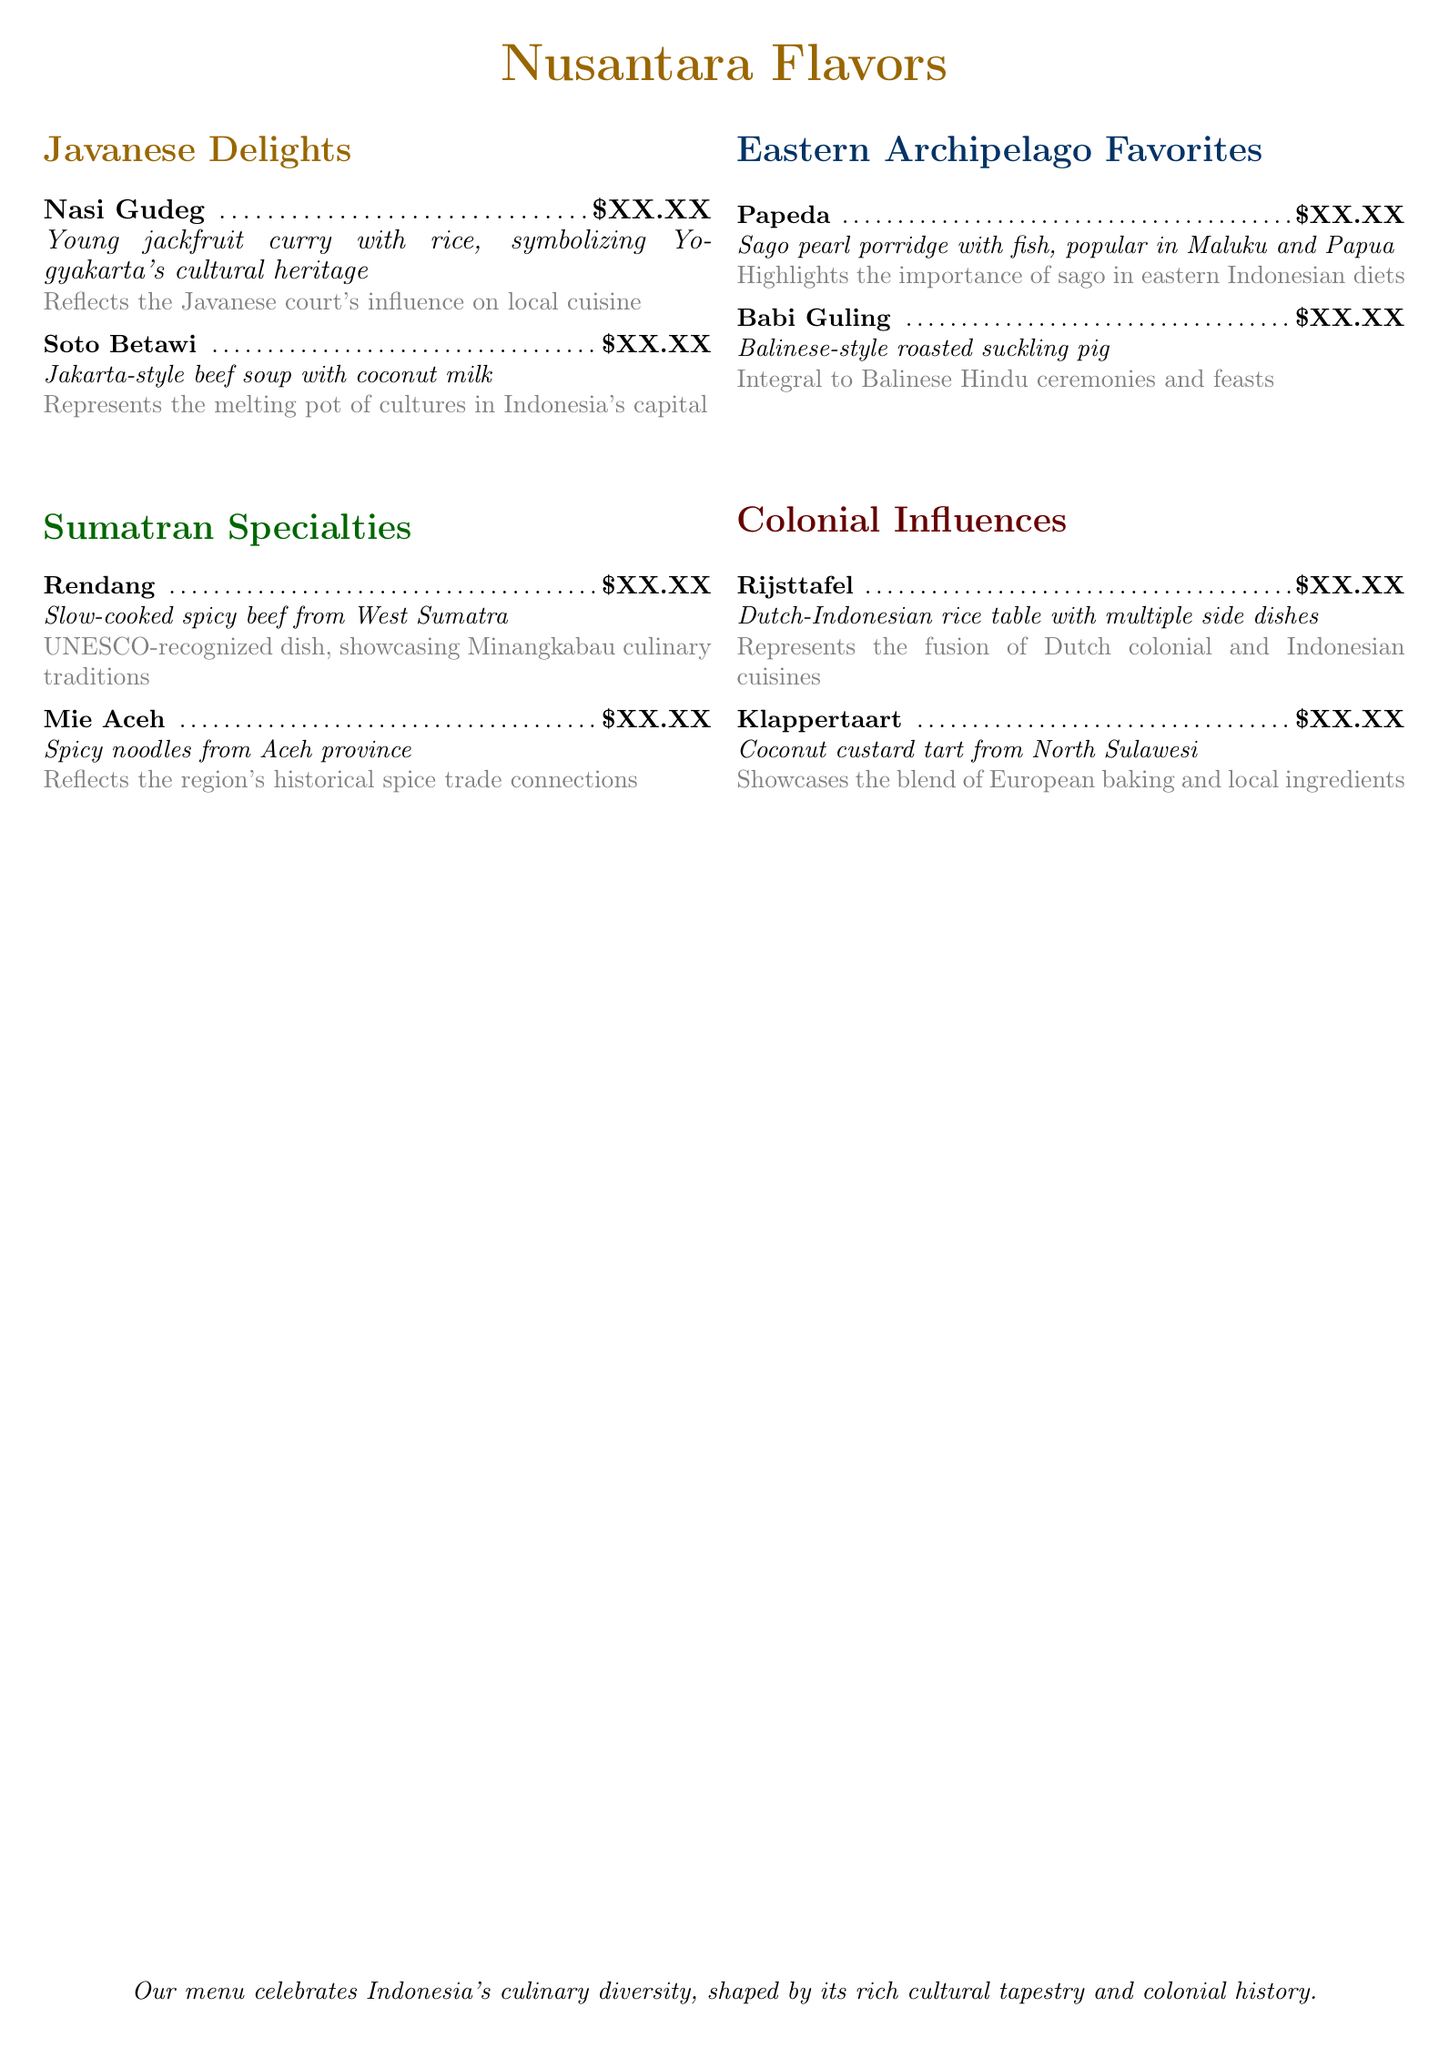What is the first dish listed under Javanese Delights? The first dish mentioned in the Javanese Delights section is Nasi Gudeg.
Answer: Nasi Gudeg What type of cuisine is Rijsttafel? Rijsttafel represents a fusion of Dutch colonial and Indonesian cuisines.
Answer: Dutch-Indonesian Which dish is recognized by UNESCO? Rendang is the dish that is UNESCO-recognized.
Answer: Rendang What is the main ingredient in Papeda? Papeda is primarily made with sago pearls.
Answer: Sago pearl What cultural aspect does Babi Guling relate to? Babi Guling is integral to Balinese Hindu ceremonies and feasts.
Answer: Balinese Hindu ceremonies How many regional specialties are listed in the menu? The menu lists dishes from four distinct regions.
Answer: Four What beverage accompanies the menu? The menu does not specify a beverage.
Answer: None Which dish represents the melting pot of cultures in Indonesia's capital? Soto Betawi represents the melting pot of cultures.
Answer: Soto Betawi What is the price format shown on the menu? The price format indicates "XX.XX" for the dishes.
Answer: XX.XX 